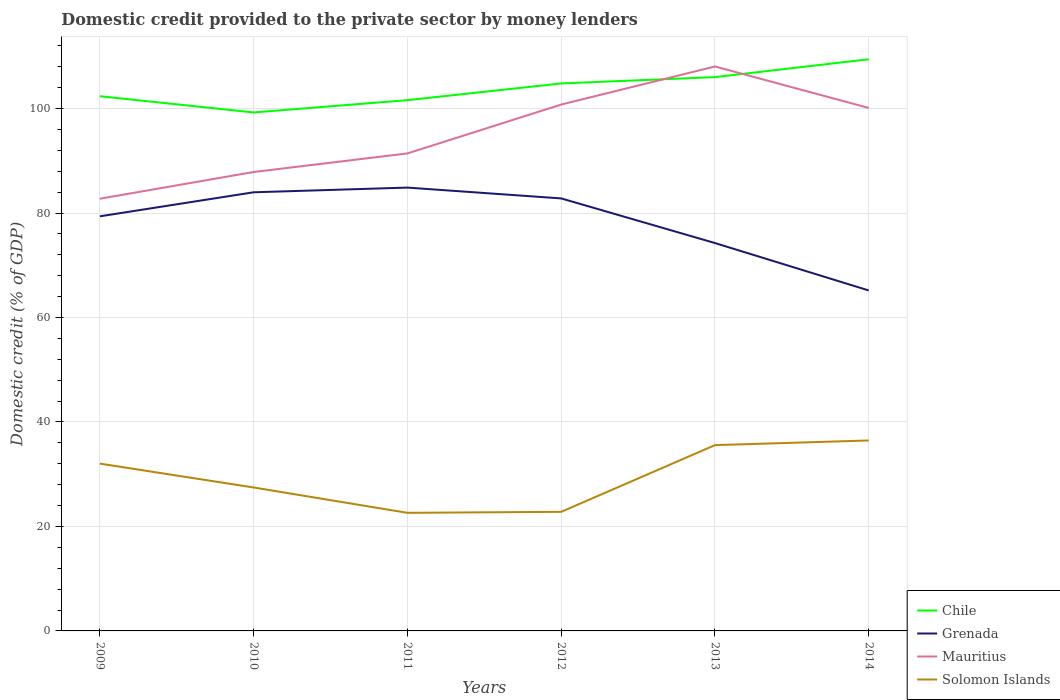How many different coloured lines are there?
Give a very brief answer. 4. Across all years, what is the maximum domestic credit provided to the private sector by money lenders in Chile?
Give a very brief answer. 99.27. What is the total domestic credit provided to the private sector by money lenders in Chile in the graph?
Your response must be concise. -5.55. What is the difference between the highest and the second highest domestic credit provided to the private sector by money lenders in Mauritius?
Make the answer very short. 25.33. What is the difference between the highest and the lowest domestic credit provided to the private sector by money lenders in Grenada?
Offer a terse response. 4. Is the domestic credit provided to the private sector by money lenders in Mauritius strictly greater than the domestic credit provided to the private sector by money lenders in Chile over the years?
Your answer should be very brief. No. Does the graph contain any zero values?
Offer a very short reply. No. How many legend labels are there?
Offer a terse response. 4. What is the title of the graph?
Your answer should be compact. Domestic credit provided to the private sector by money lenders. What is the label or title of the X-axis?
Ensure brevity in your answer.  Years. What is the label or title of the Y-axis?
Offer a very short reply. Domestic credit (% of GDP). What is the Domestic credit (% of GDP) of Chile in 2009?
Your answer should be compact. 102.37. What is the Domestic credit (% of GDP) in Grenada in 2009?
Provide a succinct answer. 79.38. What is the Domestic credit (% of GDP) of Mauritius in 2009?
Give a very brief answer. 82.74. What is the Domestic credit (% of GDP) of Solomon Islands in 2009?
Offer a terse response. 32.03. What is the Domestic credit (% of GDP) in Chile in 2010?
Your answer should be very brief. 99.27. What is the Domestic credit (% of GDP) of Grenada in 2010?
Provide a short and direct response. 83.98. What is the Domestic credit (% of GDP) in Mauritius in 2010?
Offer a very short reply. 87.86. What is the Domestic credit (% of GDP) in Solomon Islands in 2010?
Your response must be concise. 27.46. What is the Domestic credit (% of GDP) in Chile in 2011?
Provide a short and direct response. 101.62. What is the Domestic credit (% of GDP) in Grenada in 2011?
Your answer should be compact. 84.88. What is the Domestic credit (% of GDP) of Mauritius in 2011?
Ensure brevity in your answer.  91.42. What is the Domestic credit (% of GDP) of Solomon Islands in 2011?
Keep it short and to the point. 22.61. What is the Domestic credit (% of GDP) of Chile in 2012?
Offer a terse response. 104.82. What is the Domestic credit (% of GDP) of Grenada in 2012?
Your response must be concise. 82.8. What is the Domestic credit (% of GDP) of Mauritius in 2012?
Make the answer very short. 100.77. What is the Domestic credit (% of GDP) of Solomon Islands in 2012?
Your answer should be very brief. 22.8. What is the Domestic credit (% of GDP) in Chile in 2013?
Provide a short and direct response. 106.03. What is the Domestic credit (% of GDP) in Grenada in 2013?
Offer a very short reply. 74.26. What is the Domestic credit (% of GDP) in Mauritius in 2013?
Keep it short and to the point. 108.07. What is the Domestic credit (% of GDP) in Solomon Islands in 2013?
Offer a very short reply. 35.57. What is the Domestic credit (% of GDP) of Chile in 2014?
Offer a terse response. 109.45. What is the Domestic credit (% of GDP) of Grenada in 2014?
Provide a short and direct response. 65.18. What is the Domestic credit (% of GDP) of Mauritius in 2014?
Provide a succinct answer. 100.12. What is the Domestic credit (% of GDP) in Solomon Islands in 2014?
Ensure brevity in your answer.  36.46. Across all years, what is the maximum Domestic credit (% of GDP) of Chile?
Your answer should be compact. 109.45. Across all years, what is the maximum Domestic credit (% of GDP) in Grenada?
Provide a succinct answer. 84.88. Across all years, what is the maximum Domestic credit (% of GDP) of Mauritius?
Ensure brevity in your answer.  108.07. Across all years, what is the maximum Domestic credit (% of GDP) in Solomon Islands?
Give a very brief answer. 36.46. Across all years, what is the minimum Domestic credit (% of GDP) in Chile?
Offer a very short reply. 99.27. Across all years, what is the minimum Domestic credit (% of GDP) of Grenada?
Offer a very short reply. 65.18. Across all years, what is the minimum Domestic credit (% of GDP) in Mauritius?
Keep it short and to the point. 82.74. Across all years, what is the minimum Domestic credit (% of GDP) in Solomon Islands?
Provide a short and direct response. 22.61. What is the total Domestic credit (% of GDP) of Chile in the graph?
Your response must be concise. 623.55. What is the total Domestic credit (% of GDP) in Grenada in the graph?
Provide a short and direct response. 470.48. What is the total Domestic credit (% of GDP) of Mauritius in the graph?
Offer a very short reply. 570.99. What is the total Domestic credit (% of GDP) of Solomon Islands in the graph?
Provide a succinct answer. 176.94. What is the difference between the Domestic credit (% of GDP) in Chile in 2009 and that in 2010?
Offer a very short reply. 3.11. What is the difference between the Domestic credit (% of GDP) in Grenada in 2009 and that in 2010?
Offer a terse response. -4.6. What is the difference between the Domestic credit (% of GDP) of Mauritius in 2009 and that in 2010?
Give a very brief answer. -5.12. What is the difference between the Domestic credit (% of GDP) of Solomon Islands in 2009 and that in 2010?
Ensure brevity in your answer.  4.57. What is the difference between the Domestic credit (% of GDP) in Chile in 2009 and that in 2011?
Provide a short and direct response. 0.76. What is the difference between the Domestic credit (% of GDP) of Grenada in 2009 and that in 2011?
Your answer should be very brief. -5.5. What is the difference between the Domestic credit (% of GDP) of Mauritius in 2009 and that in 2011?
Your response must be concise. -8.67. What is the difference between the Domestic credit (% of GDP) of Solomon Islands in 2009 and that in 2011?
Your answer should be compact. 9.42. What is the difference between the Domestic credit (% of GDP) of Chile in 2009 and that in 2012?
Your response must be concise. -2.44. What is the difference between the Domestic credit (% of GDP) in Grenada in 2009 and that in 2012?
Provide a succinct answer. -3.43. What is the difference between the Domestic credit (% of GDP) of Mauritius in 2009 and that in 2012?
Ensure brevity in your answer.  -18.03. What is the difference between the Domestic credit (% of GDP) of Solomon Islands in 2009 and that in 2012?
Provide a succinct answer. 9.23. What is the difference between the Domestic credit (% of GDP) of Chile in 2009 and that in 2013?
Your response must be concise. -3.66. What is the difference between the Domestic credit (% of GDP) in Grenada in 2009 and that in 2013?
Offer a very short reply. 5.12. What is the difference between the Domestic credit (% of GDP) of Mauritius in 2009 and that in 2013?
Offer a terse response. -25.33. What is the difference between the Domestic credit (% of GDP) in Solomon Islands in 2009 and that in 2013?
Keep it short and to the point. -3.54. What is the difference between the Domestic credit (% of GDP) of Chile in 2009 and that in 2014?
Make the answer very short. -7.08. What is the difference between the Domestic credit (% of GDP) of Grenada in 2009 and that in 2014?
Offer a very short reply. 14.19. What is the difference between the Domestic credit (% of GDP) in Mauritius in 2009 and that in 2014?
Your response must be concise. -17.38. What is the difference between the Domestic credit (% of GDP) of Solomon Islands in 2009 and that in 2014?
Your response must be concise. -4.43. What is the difference between the Domestic credit (% of GDP) in Chile in 2010 and that in 2011?
Make the answer very short. -2.35. What is the difference between the Domestic credit (% of GDP) of Grenada in 2010 and that in 2011?
Your response must be concise. -0.9. What is the difference between the Domestic credit (% of GDP) of Mauritius in 2010 and that in 2011?
Your answer should be very brief. -3.55. What is the difference between the Domestic credit (% of GDP) in Solomon Islands in 2010 and that in 2011?
Offer a terse response. 4.85. What is the difference between the Domestic credit (% of GDP) in Chile in 2010 and that in 2012?
Your answer should be very brief. -5.55. What is the difference between the Domestic credit (% of GDP) in Grenada in 2010 and that in 2012?
Your answer should be compact. 1.18. What is the difference between the Domestic credit (% of GDP) of Mauritius in 2010 and that in 2012?
Keep it short and to the point. -12.91. What is the difference between the Domestic credit (% of GDP) of Solomon Islands in 2010 and that in 2012?
Your answer should be very brief. 4.66. What is the difference between the Domestic credit (% of GDP) of Chile in 2010 and that in 2013?
Provide a succinct answer. -6.76. What is the difference between the Domestic credit (% of GDP) in Grenada in 2010 and that in 2013?
Your answer should be very brief. 9.72. What is the difference between the Domestic credit (% of GDP) of Mauritius in 2010 and that in 2013?
Your answer should be very brief. -20.21. What is the difference between the Domestic credit (% of GDP) in Solomon Islands in 2010 and that in 2013?
Your answer should be compact. -8.11. What is the difference between the Domestic credit (% of GDP) in Chile in 2010 and that in 2014?
Your response must be concise. -10.18. What is the difference between the Domestic credit (% of GDP) in Grenada in 2010 and that in 2014?
Your answer should be very brief. 18.8. What is the difference between the Domestic credit (% of GDP) in Mauritius in 2010 and that in 2014?
Offer a terse response. -12.26. What is the difference between the Domestic credit (% of GDP) of Solomon Islands in 2010 and that in 2014?
Keep it short and to the point. -9. What is the difference between the Domestic credit (% of GDP) in Chile in 2011 and that in 2012?
Make the answer very short. -3.2. What is the difference between the Domestic credit (% of GDP) of Grenada in 2011 and that in 2012?
Keep it short and to the point. 2.07. What is the difference between the Domestic credit (% of GDP) of Mauritius in 2011 and that in 2012?
Ensure brevity in your answer.  -9.36. What is the difference between the Domestic credit (% of GDP) of Solomon Islands in 2011 and that in 2012?
Keep it short and to the point. -0.19. What is the difference between the Domestic credit (% of GDP) in Chile in 2011 and that in 2013?
Your answer should be compact. -4.41. What is the difference between the Domestic credit (% of GDP) of Grenada in 2011 and that in 2013?
Offer a very short reply. 10.62. What is the difference between the Domestic credit (% of GDP) in Mauritius in 2011 and that in 2013?
Provide a succinct answer. -16.65. What is the difference between the Domestic credit (% of GDP) of Solomon Islands in 2011 and that in 2013?
Give a very brief answer. -12.96. What is the difference between the Domestic credit (% of GDP) in Chile in 2011 and that in 2014?
Offer a terse response. -7.83. What is the difference between the Domestic credit (% of GDP) of Grenada in 2011 and that in 2014?
Your response must be concise. 19.69. What is the difference between the Domestic credit (% of GDP) of Mauritius in 2011 and that in 2014?
Keep it short and to the point. -8.71. What is the difference between the Domestic credit (% of GDP) in Solomon Islands in 2011 and that in 2014?
Provide a short and direct response. -13.85. What is the difference between the Domestic credit (% of GDP) of Chile in 2012 and that in 2013?
Your answer should be very brief. -1.21. What is the difference between the Domestic credit (% of GDP) in Grenada in 2012 and that in 2013?
Your answer should be very brief. 8.54. What is the difference between the Domestic credit (% of GDP) in Mauritius in 2012 and that in 2013?
Your response must be concise. -7.29. What is the difference between the Domestic credit (% of GDP) in Solomon Islands in 2012 and that in 2013?
Offer a very short reply. -12.77. What is the difference between the Domestic credit (% of GDP) of Chile in 2012 and that in 2014?
Provide a succinct answer. -4.63. What is the difference between the Domestic credit (% of GDP) in Grenada in 2012 and that in 2014?
Make the answer very short. 17.62. What is the difference between the Domestic credit (% of GDP) in Mauritius in 2012 and that in 2014?
Offer a very short reply. 0.65. What is the difference between the Domestic credit (% of GDP) of Solomon Islands in 2012 and that in 2014?
Your answer should be very brief. -13.66. What is the difference between the Domestic credit (% of GDP) of Chile in 2013 and that in 2014?
Offer a very short reply. -3.42. What is the difference between the Domestic credit (% of GDP) in Grenada in 2013 and that in 2014?
Your answer should be compact. 9.08. What is the difference between the Domestic credit (% of GDP) in Mauritius in 2013 and that in 2014?
Keep it short and to the point. 7.94. What is the difference between the Domestic credit (% of GDP) in Solomon Islands in 2013 and that in 2014?
Give a very brief answer. -0.89. What is the difference between the Domestic credit (% of GDP) of Chile in 2009 and the Domestic credit (% of GDP) of Grenada in 2010?
Keep it short and to the point. 18.39. What is the difference between the Domestic credit (% of GDP) of Chile in 2009 and the Domestic credit (% of GDP) of Mauritius in 2010?
Provide a short and direct response. 14.51. What is the difference between the Domestic credit (% of GDP) of Chile in 2009 and the Domestic credit (% of GDP) of Solomon Islands in 2010?
Offer a very short reply. 74.91. What is the difference between the Domestic credit (% of GDP) of Grenada in 2009 and the Domestic credit (% of GDP) of Mauritius in 2010?
Your response must be concise. -8.49. What is the difference between the Domestic credit (% of GDP) of Grenada in 2009 and the Domestic credit (% of GDP) of Solomon Islands in 2010?
Ensure brevity in your answer.  51.91. What is the difference between the Domestic credit (% of GDP) of Mauritius in 2009 and the Domestic credit (% of GDP) of Solomon Islands in 2010?
Make the answer very short. 55.28. What is the difference between the Domestic credit (% of GDP) in Chile in 2009 and the Domestic credit (% of GDP) in Grenada in 2011?
Offer a very short reply. 17.5. What is the difference between the Domestic credit (% of GDP) of Chile in 2009 and the Domestic credit (% of GDP) of Mauritius in 2011?
Your answer should be very brief. 10.96. What is the difference between the Domestic credit (% of GDP) in Chile in 2009 and the Domestic credit (% of GDP) in Solomon Islands in 2011?
Your answer should be compact. 79.76. What is the difference between the Domestic credit (% of GDP) of Grenada in 2009 and the Domestic credit (% of GDP) of Mauritius in 2011?
Make the answer very short. -12.04. What is the difference between the Domestic credit (% of GDP) in Grenada in 2009 and the Domestic credit (% of GDP) in Solomon Islands in 2011?
Your answer should be compact. 56.77. What is the difference between the Domestic credit (% of GDP) of Mauritius in 2009 and the Domestic credit (% of GDP) of Solomon Islands in 2011?
Provide a short and direct response. 60.13. What is the difference between the Domestic credit (% of GDP) in Chile in 2009 and the Domestic credit (% of GDP) in Grenada in 2012?
Keep it short and to the point. 19.57. What is the difference between the Domestic credit (% of GDP) of Chile in 2009 and the Domestic credit (% of GDP) of Mauritius in 2012?
Give a very brief answer. 1.6. What is the difference between the Domestic credit (% of GDP) of Chile in 2009 and the Domestic credit (% of GDP) of Solomon Islands in 2012?
Offer a very short reply. 79.57. What is the difference between the Domestic credit (% of GDP) of Grenada in 2009 and the Domestic credit (% of GDP) of Mauritius in 2012?
Your answer should be very brief. -21.4. What is the difference between the Domestic credit (% of GDP) in Grenada in 2009 and the Domestic credit (% of GDP) in Solomon Islands in 2012?
Ensure brevity in your answer.  56.58. What is the difference between the Domestic credit (% of GDP) in Mauritius in 2009 and the Domestic credit (% of GDP) in Solomon Islands in 2012?
Make the answer very short. 59.94. What is the difference between the Domestic credit (% of GDP) of Chile in 2009 and the Domestic credit (% of GDP) of Grenada in 2013?
Your response must be concise. 28.11. What is the difference between the Domestic credit (% of GDP) of Chile in 2009 and the Domestic credit (% of GDP) of Mauritius in 2013?
Offer a terse response. -5.7. What is the difference between the Domestic credit (% of GDP) in Chile in 2009 and the Domestic credit (% of GDP) in Solomon Islands in 2013?
Offer a very short reply. 66.8. What is the difference between the Domestic credit (% of GDP) in Grenada in 2009 and the Domestic credit (% of GDP) in Mauritius in 2013?
Keep it short and to the point. -28.69. What is the difference between the Domestic credit (% of GDP) in Grenada in 2009 and the Domestic credit (% of GDP) in Solomon Islands in 2013?
Your response must be concise. 43.8. What is the difference between the Domestic credit (% of GDP) of Mauritius in 2009 and the Domestic credit (% of GDP) of Solomon Islands in 2013?
Offer a terse response. 47.17. What is the difference between the Domestic credit (% of GDP) in Chile in 2009 and the Domestic credit (% of GDP) in Grenada in 2014?
Offer a very short reply. 37.19. What is the difference between the Domestic credit (% of GDP) in Chile in 2009 and the Domestic credit (% of GDP) in Mauritius in 2014?
Your answer should be very brief. 2.25. What is the difference between the Domestic credit (% of GDP) of Chile in 2009 and the Domestic credit (% of GDP) of Solomon Islands in 2014?
Offer a terse response. 65.91. What is the difference between the Domestic credit (% of GDP) of Grenada in 2009 and the Domestic credit (% of GDP) of Mauritius in 2014?
Provide a succinct answer. -20.75. What is the difference between the Domestic credit (% of GDP) of Grenada in 2009 and the Domestic credit (% of GDP) of Solomon Islands in 2014?
Give a very brief answer. 42.91. What is the difference between the Domestic credit (% of GDP) in Mauritius in 2009 and the Domestic credit (% of GDP) in Solomon Islands in 2014?
Offer a terse response. 46.28. What is the difference between the Domestic credit (% of GDP) in Chile in 2010 and the Domestic credit (% of GDP) in Grenada in 2011?
Give a very brief answer. 14.39. What is the difference between the Domestic credit (% of GDP) of Chile in 2010 and the Domestic credit (% of GDP) of Mauritius in 2011?
Your answer should be compact. 7.85. What is the difference between the Domestic credit (% of GDP) of Chile in 2010 and the Domestic credit (% of GDP) of Solomon Islands in 2011?
Offer a very short reply. 76.65. What is the difference between the Domestic credit (% of GDP) of Grenada in 2010 and the Domestic credit (% of GDP) of Mauritius in 2011?
Your answer should be compact. -7.44. What is the difference between the Domestic credit (% of GDP) in Grenada in 2010 and the Domestic credit (% of GDP) in Solomon Islands in 2011?
Make the answer very short. 61.37. What is the difference between the Domestic credit (% of GDP) of Mauritius in 2010 and the Domestic credit (% of GDP) of Solomon Islands in 2011?
Keep it short and to the point. 65.25. What is the difference between the Domestic credit (% of GDP) in Chile in 2010 and the Domestic credit (% of GDP) in Grenada in 2012?
Give a very brief answer. 16.46. What is the difference between the Domestic credit (% of GDP) of Chile in 2010 and the Domestic credit (% of GDP) of Mauritius in 2012?
Keep it short and to the point. -1.51. What is the difference between the Domestic credit (% of GDP) of Chile in 2010 and the Domestic credit (% of GDP) of Solomon Islands in 2012?
Your response must be concise. 76.47. What is the difference between the Domestic credit (% of GDP) of Grenada in 2010 and the Domestic credit (% of GDP) of Mauritius in 2012?
Provide a succinct answer. -16.79. What is the difference between the Domestic credit (% of GDP) of Grenada in 2010 and the Domestic credit (% of GDP) of Solomon Islands in 2012?
Make the answer very short. 61.18. What is the difference between the Domestic credit (% of GDP) in Mauritius in 2010 and the Domestic credit (% of GDP) in Solomon Islands in 2012?
Ensure brevity in your answer.  65.06. What is the difference between the Domestic credit (% of GDP) of Chile in 2010 and the Domestic credit (% of GDP) of Grenada in 2013?
Make the answer very short. 25. What is the difference between the Domestic credit (% of GDP) in Chile in 2010 and the Domestic credit (% of GDP) in Mauritius in 2013?
Provide a short and direct response. -8.8. What is the difference between the Domestic credit (% of GDP) in Chile in 2010 and the Domestic credit (% of GDP) in Solomon Islands in 2013?
Offer a very short reply. 63.69. What is the difference between the Domestic credit (% of GDP) of Grenada in 2010 and the Domestic credit (% of GDP) of Mauritius in 2013?
Keep it short and to the point. -24.09. What is the difference between the Domestic credit (% of GDP) of Grenada in 2010 and the Domestic credit (% of GDP) of Solomon Islands in 2013?
Keep it short and to the point. 48.41. What is the difference between the Domestic credit (% of GDP) of Mauritius in 2010 and the Domestic credit (% of GDP) of Solomon Islands in 2013?
Your answer should be compact. 52.29. What is the difference between the Domestic credit (% of GDP) of Chile in 2010 and the Domestic credit (% of GDP) of Grenada in 2014?
Make the answer very short. 34.08. What is the difference between the Domestic credit (% of GDP) in Chile in 2010 and the Domestic credit (% of GDP) in Mauritius in 2014?
Give a very brief answer. -0.86. What is the difference between the Domestic credit (% of GDP) in Chile in 2010 and the Domestic credit (% of GDP) in Solomon Islands in 2014?
Offer a terse response. 62.8. What is the difference between the Domestic credit (% of GDP) in Grenada in 2010 and the Domestic credit (% of GDP) in Mauritius in 2014?
Offer a terse response. -16.14. What is the difference between the Domestic credit (% of GDP) in Grenada in 2010 and the Domestic credit (% of GDP) in Solomon Islands in 2014?
Provide a short and direct response. 47.52. What is the difference between the Domestic credit (% of GDP) in Mauritius in 2010 and the Domestic credit (% of GDP) in Solomon Islands in 2014?
Your response must be concise. 51.4. What is the difference between the Domestic credit (% of GDP) of Chile in 2011 and the Domestic credit (% of GDP) of Grenada in 2012?
Your answer should be compact. 18.81. What is the difference between the Domestic credit (% of GDP) of Chile in 2011 and the Domestic credit (% of GDP) of Mauritius in 2012?
Provide a short and direct response. 0.84. What is the difference between the Domestic credit (% of GDP) of Chile in 2011 and the Domestic credit (% of GDP) of Solomon Islands in 2012?
Your answer should be very brief. 78.82. What is the difference between the Domestic credit (% of GDP) of Grenada in 2011 and the Domestic credit (% of GDP) of Mauritius in 2012?
Offer a terse response. -15.9. What is the difference between the Domestic credit (% of GDP) of Grenada in 2011 and the Domestic credit (% of GDP) of Solomon Islands in 2012?
Your response must be concise. 62.08. What is the difference between the Domestic credit (% of GDP) in Mauritius in 2011 and the Domestic credit (% of GDP) in Solomon Islands in 2012?
Offer a very short reply. 68.62. What is the difference between the Domestic credit (% of GDP) of Chile in 2011 and the Domestic credit (% of GDP) of Grenada in 2013?
Keep it short and to the point. 27.36. What is the difference between the Domestic credit (% of GDP) of Chile in 2011 and the Domestic credit (% of GDP) of Mauritius in 2013?
Your answer should be compact. -6.45. What is the difference between the Domestic credit (% of GDP) of Chile in 2011 and the Domestic credit (% of GDP) of Solomon Islands in 2013?
Make the answer very short. 66.04. What is the difference between the Domestic credit (% of GDP) of Grenada in 2011 and the Domestic credit (% of GDP) of Mauritius in 2013?
Make the answer very short. -23.19. What is the difference between the Domestic credit (% of GDP) of Grenada in 2011 and the Domestic credit (% of GDP) of Solomon Islands in 2013?
Offer a terse response. 49.3. What is the difference between the Domestic credit (% of GDP) in Mauritius in 2011 and the Domestic credit (% of GDP) in Solomon Islands in 2013?
Your response must be concise. 55.84. What is the difference between the Domestic credit (% of GDP) in Chile in 2011 and the Domestic credit (% of GDP) in Grenada in 2014?
Make the answer very short. 36.43. What is the difference between the Domestic credit (% of GDP) of Chile in 2011 and the Domestic credit (% of GDP) of Mauritius in 2014?
Make the answer very short. 1.49. What is the difference between the Domestic credit (% of GDP) in Chile in 2011 and the Domestic credit (% of GDP) in Solomon Islands in 2014?
Make the answer very short. 65.15. What is the difference between the Domestic credit (% of GDP) of Grenada in 2011 and the Domestic credit (% of GDP) of Mauritius in 2014?
Ensure brevity in your answer.  -15.25. What is the difference between the Domestic credit (% of GDP) in Grenada in 2011 and the Domestic credit (% of GDP) in Solomon Islands in 2014?
Keep it short and to the point. 48.41. What is the difference between the Domestic credit (% of GDP) in Mauritius in 2011 and the Domestic credit (% of GDP) in Solomon Islands in 2014?
Provide a short and direct response. 54.95. What is the difference between the Domestic credit (% of GDP) of Chile in 2012 and the Domestic credit (% of GDP) of Grenada in 2013?
Your response must be concise. 30.56. What is the difference between the Domestic credit (% of GDP) of Chile in 2012 and the Domestic credit (% of GDP) of Mauritius in 2013?
Ensure brevity in your answer.  -3.25. What is the difference between the Domestic credit (% of GDP) of Chile in 2012 and the Domestic credit (% of GDP) of Solomon Islands in 2013?
Offer a terse response. 69.24. What is the difference between the Domestic credit (% of GDP) in Grenada in 2012 and the Domestic credit (% of GDP) in Mauritius in 2013?
Offer a very short reply. -25.26. What is the difference between the Domestic credit (% of GDP) of Grenada in 2012 and the Domestic credit (% of GDP) of Solomon Islands in 2013?
Ensure brevity in your answer.  47.23. What is the difference between the Domestic credit (% of GDP) in Mauritius in 2012 and the Domestic credit (% of GDP) in Solomon Islands in 2013?
Offer a very short reply. 65.2. What is the difference between the Domestic credit (% of GDP) of Chile in 2012 and the Domestic credit (% of GDP) of Grenada in 2014?
Give a very brief answer. 39.63. What is the difference between the Domestic credit (% of GDP) in Chile in 2012 and the Domestic credit (% of GDP) in Mauritius in 2014?
Provide a succinct answer. 4.69. What is the difference between the Domestic credit (% of GDP) in Chile in 2012 and the Domestic credit (% of GDP) in Solomon Islands in 2014?
Make the answer very short. 68.35. What is the difference between the Domestic credit (% of GDP) of Grenada in 2012 and the Domestic credit (% of GDP) of Mauritius in 2014?
Provide a succinct answer. -17.32. What is the difference between the Domestic credit (% of GDP) in Grenada in 2012 and the Domestic credit (% of GDP) in Solomon Islands in 2014?
Keep it short and to the point. 46.34. What is the difference between the Domestic credit (% of GDP) of Mauritius in 2012 and the Domestic credit (% of GDP) of Solomon Islands in 2014?
Offer a very short reply. 64.31. What is the difference between the Domestic credit (% of GDP) in Chile in 2013 and the Domestic credit (% of GDP) in Grenada in 2014?
Your response must be concise. 40.84. What is the difference between the Domestic credit (% of GDP) in Chile in 2013 and the Domestic credit (% of GDP) in Mauritius in 2014?
Your answer should be compact. 5.9. What is the difference between the Domestic credit (% of GDP) in Chile in 2013 and the Domestic credit (% of GDP) in Solomon Islands in 2014?
Make the answer very short. 69.56. What is the difference between the Domestic credit (% of GDP) of Grenada in 2013 and the Domestic credit (% of GDP) of Mauritius in 2014?
Your answer should be compact. -25.86. What is the difference between the Domestic credit (% of GDP) in Grenada in 2013 and the Domestic credit (% of GDP) in Solomon Islands in 2014?
Your answer should be very brief. 37.8. What is the difference between the Domestic credit (% of GDP) in Mauritius in 2013 and the Domestic credit (% of GDP) in Solomon Islands in 2014?
Your answer should be compact. 71.6. What is the average Domestic credit (% of GDP) in Chile per year?
Ensure brevity in your answer.  103.92. What is the average Domestic credit (% of GDP) in Grenada per year?
Give a very brief answer. 78.41. What is the average Domestic credit (% of GDP) in Mauritius per year?
Provide a succinct answer. 95.16. What is the average Domestic credit (% of GDP) in Solomon Islands per year?
Offer a terse response. 29.49. In the year 2009, what is the difference between the Domestic credit (% of GDP) of Chile and Domestic credit (% of GDP) of Grenada?
Offer a very short reply. 23. In the year 2009, what is the difference between the Domestic credit (% of GDP) in Chile and Domestic credit (% of GDP) in Mauritius?
Your answer should be compact. 19.63. In the year 2009, what is the difference between the Domestic credit (% of GDP) of Chile and Domestic credit (% of GDP) of Solomon Islands?
Make the answer very short. 70.34. In the year 2009, what is the difference between the Domestic credit (% of GDP) of Grenada and Domestic credit (% of GDP) of Mauritius?
Give a very brief answer. -3.37. In the year 2009, what is the difference between the Domestic credit (% of GDP) of Grenada and Domestic credit (% of GDP) of Solomon Islands?
Keep it short and to the point. 47.35. In the year 2009, what is the difference between the Domestic credit (% of GDP) of Mauritius and Domestic credit (% of GDP) of Solomon Islands?
Offer a very short reply. 50.71. In the year 2010, what is the difference between the Domestic credit (% of GDP) of Chile and Domestic credit (% of GDP) of Grenada?
Your response must be concise. 15.29. In the year 2010, what is the difference between the Domestic credit (% of GDP) of Chile and Domestic credit (% of GDP) of Mauritius?
Provide a succinct answer. 11.4. In the year 2010, what is the difference between the Domestic credit (% of GDP) in Chile and Domestic credit (% of GDP) in Solomon Islands?
Your answer should be very brief. 71.8. In the year 2010, what is the difference between the Domestic credit (% of GDP) of Grenada and Domestic credit (% of GDP) of Mauritius?
Your answer should be very brief. -3.88. In the year 2010, what is the difference between the Domestic credit (% of GDP) of Grenada and Domestic credit (% of GDP) of Solomon Islands?
Your response must be concise. 56.52. In the year 2010, what is the difference between the Domestic credit (% of GDP) in Mauritius and Domestic credit (% of GDP) in Solomon Islands?
Offer a terse response. 60.4. In the year 2011, what is the difference between the Domestic credit (% of GDP) in Chile and Domestic credit (% of GDP) in Grenada?
Ensure brevity in your answer.  16.74. In the year 2011, what is the difference between the Domestic credit (% of GDP) of Chile and Domestic credit (% of GDP) of Mauritius?
Give a very brief answer. 10.2. In the year 2011, what is the difference between the Domestic credit (% of GDP) of Chile and Domestic credit (% of GDP) of Solomon Islands?
Keep it short and to the point. 79.01. In the year 2011, what is the difference between the Domestic credit (% of GDP) in Grenada and Domestic credit (% of GDP) in Mauritius?
Ensure brevity in your answer.  -6.54. In the year 2011, what is the difference between the Domestic credit (% of GDP) of Grenada and Domestic credit (% of GDP) of Solomon Islands?
Offer a very short reply. 62.27. In the year 2011, what is the difference between the Domestic credit (% of GDP) of Mauritius and Domestic credit (% of GDP) of Solomon Islands?
Your response must be concise. 68.81. In the year 2012, what is the difference between the Domestic credit (% of GDP) of Chile and Domestic credit (% of GDP) of Grenada?
Your response must be concise. 22.01. In the year 2012, what is the difference between the Domestic credit (% of GDP) of Chile and Domestic credit (% of GDP) of Mauritius?
Offer a terse response. 4.04. In the year 2012, what is the difference between the Domestic credit (% of GDP) of Chile and Domestic credit (% of GDP) of Solomon Islands?
Offer a terse response. 82.02. In the year 2012, what is the difference between the Domestic credit (% of GDP) in Grenada and Domestic credit (% of GDP) in Mauritius?
Make the answer very short. -17.97. In the year 2012, what is the difference between the Domestic credit (% of GDP) in Grenada and Domestic credit (% of GDP) in Solomon Islands?
Your answer should be compact. 60. In the year 2012, what is the difference between the Domestic credit (% of GDP) of Mauritius and Domestic credit (% of GDP) of Solomon Islands?
Offer a terse response. 77.97. In the year 2013, what is the difference between the Domestic credit (% of GDP) of Chile and Domestic credit (% of GDP) of Grenada?
Provide a succinct answer. 31.77. In the year 2013, what is the difference between the Domestic credit (% of GDP) in Chile and Domestic credit (% of GDP) in Mauritius?
Your answer should be very brief. -2.04. In the year 2013, what is the difference between the Domestic credit (% of GDP) in Chile and Domestic credit (% of GDP) in Solomon Islands?
Provide a short and direct response. 70.46. In the year 2013, what is the difference between the Domestic credit (% of GDP) in Grenada and Domestic credit (% of GDP) in Mauritius?
Provide a succinct answer. -33.81. In the year 2013, what is the difference between the Domestic credit (% of GDP) of Grenada and Domestic credit (% of GDP) of Solomon Islands?
Make the answer very short. 38.69. In the year 2013, what is the difference between the Domestic credit (% of GDP) of Mauritius and Domestic credit (% of GDP) of Solomon Islands?
Give a very brief answer. 72.5. In the year 2014, what is the difference between the Domestic credit (% of GDP) of Chile and Domestic credit (% of GDP) of Grenada?
Your answer should be very brief. 44.26. In the year 2014, what is the difference between the Domestic credit (% of GDP) in Chile and Domestic credit (% of GDP) in Mauritius?
Provide a succinct answer. 9.32. In the year 2014, what is the difference between the Domestic credit (% of GDP) in Chile and Domestic credit (% of GDP) in Solomon Islands?
Your answer should be very brief. 72.98. In the year 2014, what is the difference between the Domestic credit (% of GDP) of Grenada and Domestic credit (% of GDP) of Mauritius?
Offer a terse response. -34.94. In the year 2014, what is the difference between the Domestic credit (% of GDP) in Grenada and Domestic credit (% of GDP) in Solomon Islands?
Provide a short and direct response. 28.72. In the year 2014, what is the difference between the Domestic credit (% of GDP) in Mauritius and Domestic credit (% of GDP) in Solomon Islands?
Give a very brief answer. 63.66. What is the ratio of the Domestic credit (% of GDP) in Chile in 2009 to that in 2010?
Offer a very short reply. 1.03. What is the ratio of the Domestic credit (% of GDP) of Grenada in 2009 to that in 2010?
Your response must be concise. 0.95. What is the ratio of the Domestic credit (% of GDP) of Mauritius in 2009 to that in 2010?
Ensure brevity in your answer.  0.94. What is the ratio of the Domestic credit (% of GDP) in Solomon Islands in 2009 to that in 2010?
Offer a terse response. 1.17. What is the ratio of the Domestic credit (% of GDP) in Chile in 2009 to that in 2011?
Offer a very short reply. 1.01. What is the ratio of the Domestic credit (% of GDP) in Grenada in 2009 to that in 2011?
Your answer should be very brief. 0.94. What is the ratio of the Domestic credit (% of GDP) in Mauritius in 2009 to that in 2011?
Make the answer very short. 0.91. What is the ratio of the Domestic credit (% of GDP) of Solomon Islands in 2009 to that in 2011?
Provide a succinct answer. 1.42. What is the ratio of the Domestic credit (% of GDP) in Chile in 2009 to that in 2012?
Make the answer very short. 0.98. What is the ratio of the Domestic credit (% of GDP) of Grenada in 2009 to that in 2012?
Give a very brief answer. 0.96. What is the ratio of the Domestic credit (% of GDP) of Mauritius in 2009 to that in 2012?
Offer a very short reply. 0.82. What is the ratio of the Domestic credit (% of GDP) of Solomon Islands in 2009 to that in 2012?
Offer a terse response. 1.4. What is the ratio of the Domestic credit (% of GDP) of Chile in 2009 to that in 2013?
Offer a very short reply. 0.97. What is the ratio of the Domestic credit (% of GDP) of Grenada in 2009 to that in 2013?
Provide a short and direct response. 1.07. What is the ratio of the Domestic credit (% of GDP) of Mauritius in 2009 to that in 2013?
Provide a succinct answer. 0.77. What is the ratio of the Domestic credit (% of GDP) in Solomon Islands in 2009 to that in 2013?
Keep it short and to the point. 0.9. What is the ratio of the Domestic credit (% of GDP) in Chile in 2009 to that in 2014?
Your answer should be compact. 0.94. What is the ratio of the Domestic credit (% of GDP) of Grenada in 2009 to that in 2014?
Keep it short and to the point. 1.22. What is the ratio of the Domestic credit (% of GDP) of Mauritius in 2009 to that in 2014?
Your answer should be very brief. 0.83. What is the ratio of the Domestic credit (% of GDP) of Solomon Islands in 2009 to that in 2014?
Your answer should be very brief. 0.88. What is the ratio of the Domestic credit (% of GDP) in Chile in 2010 to that in 2011?
Offer a terse response. 0.98. What is the ratio of the Domestic credit (% of GDP) of Grenada in 2010 to that in 2011?
Give a very brief answer. 0.99. What is the ratio of the Domestic credit (% of GDP) in Mauritius in 2010 to that in 2011?
Your answer should be compact. 0.96. What is the ratio of the Domestic credit (% of GDP) of Solomon Islands in 2010 to that in 2011?
Offer a very short reply. 1.21. What is the ratio of the Domestic credit (% of GDP) in Chile in 2010 to that in 2012?
Ensure brevity in your answer.  0.95. What is the ratio of the Domestic credit (% of GDP) in Grenada in 2010 to that in 2012?
Offer a very short reply. 1.01. What is the ratio of the Domestic credit (% of GDP) in Mauritius in 2010 to that in 2012?
Your response must be concise. 0.87. What is the ratio of the Domestic credit (% of GDP) of Solomon Islands in 2010 to that in 2012?
Provide a succinct answer. 1.2. What is the ratio of the Domestic credit (% of GDP) of Chile in 2010 to that in 2013?
Your response must be concise. 0.94. What is the ratio of the Domestic credit (% of GDP) of Grenada in 2010 to that in 2013?
Provide a succinct answer. 1.13. What is the ratio of the Domestic credit (% of GDP) of Mauritius in 2010 to that in 2013?
Ensure brevity in your answer.  0.81. What is the ratio of the Domestic credit (% of GDP) in Solomon Islands in 2010 to that in 2013?
Your answer should be compact. 0.77. What is the ratio of the Domestic credit (% of GDP) in Chile in 2010 to that in 2014?
Keep it short and to the point. 0.91. What is the ratio of the Domestic credit (% of GDP) in Grenada in 2010 to that in 2014?
Make the answer very short. 1.29. What is the ratio of the Domestic credit (% of GDP) in Mauritius in 2010 to that in 2014?
Keep it short and to the point. 0.88. What is the ratio of the Domestic credit (% of GDP) of Solomon Islands in 2010 to that in 2014?
Make the answer very short. 0.75. What is the ratio of the Domestic credit (% of GDP) in Chile in 2011 to that in 2012?
Offer a very short reply. 0.97. What is the ratio of the Domestic credit (% of GDP) of Grenada in 2011 to that in 2012?
Make the answer very short. 1.02. What is the ratio of the Domestic credit (% of GDP) in Mauritius in 2011 to that in 2012?
Ensure brevity in your answer.  0.91. What is the ratio of the Domestic credit (% of GDP) of Solomon Islands in 2011 to that in 2012?
Make the answer very short. 0.99. What is the ratio of the Domestic credit (% of GDP) of Chile in 2011 to that in 2013?
Give a very brief answer. 0.96. What is the ratio of the Domestic credit (% of GDP) in Grenada in 2011 to that in 2013?
Provide a succinct answer. 1.14. What is the ratio of the Domestic credit (% of GDP) of Mauritius in 2011 to that in 2013?
Your response must be concise. 0.85. What is the ratio of the Domestic credit (% of GDP) of Solomon Islands in 2011 to that in 2013?
Your answer should be compact. 0.64. What is the ratio of the Domestic credit (% of GDP) of Chile in 2011 to that in 2014?
Provide a short and direct response. 0.93. What is the ratio of the Domestic credit (% of GDP) in Grenada in 2011 to that in 2014?
Offer a very short reply. 1.3. What is the ratio of the Domestic credit (% of GDP) in Mauritius in 2011 to that in 2014?
Your answer should be compact. 0.91. What is the ratio of the Domestic credit (% of GDP) in Solomon Islands in 2011 to that in 2014?
Offer a very short reply. 0.62. What is the ratio of the Domestic credit (% of GDP) of Grenada in 2012 to that in 2013?
Keep it short and to the point. 1.12. What is the ratio of the Domestic credit (% of GDP) in Mauritius in 2012 to that in 2013?
Make the answer very short. 0.93. What is the ratio of the Domestic credit (% of GDP) in Solomon Islands in 2012 to that in 2013?
Your answer should be very brief. 0.64. What is the ratio of the Domestic credit (% of GDP) in Chile in 2012 to that in 2014?
Your response must be concise. 0.96. What is the ratio of the Domestic credit (% of GDP) in Grenada in 2012 to that in 2014?
Your answer should be compact. 1.27. What is the ratio of the Domestic credit (% of GDP) of Solomon Islands in 2012 to that in 2014?
Offer a terse response. 0.63. What is the ratio of the Domestic credit (% of GDP) in Chile in 2013 to that in 2014?
Make the answer very short. 0.97. What is the ratio of the Domestic credit (% of GDP) in Grenada in 2013 to that in 2014?
Ensure brevity in your answer.  1.14. What is the ratio of the Domestic credit (% of GDP) in Mauritius in 2013 to that in 2014?
Offer a terse response. 1.08. What is the ratio of the Domestic credit (% of GDP) of Solomon Islands in 2013 to that in 2014?
Provide a short and direct response. 0.98. What is the difference between the highest and the second highest Domestic credit (% of GDP) in Chile?
Give a very brief answer. 3.42. What is the difference between the highest and the second highest Domestic credit (% of GDP) in Grenada?
Offer a very short reply. 0.9. What is the difference between the highest and the second highest Domestic credit (% of GDP) of Mauritius?
Offer a terse response. 7.29. What is the difference between the highest and the second highest Domestic credit (% of GDP) of Solomon Islands?
Your response must be concise. 0.89. What is the difference between the highest and the lowest Domestic credit (% of GDP) in Chile?
Give a very brief answer. 10.18. What is the difference between the highest and the lowest Domestic credit (% of GDP) in Grenada?
Keep it short and to the point. 19.69. What is the difference between the highest and the lowest Domestic credit (% of GDP) in Mauritius?
Provide a succinct answer. 25.33. What is the difference between the highest and the lowest Domestic credit (% of GDP) in Solomon Islands?
Your response must be concise. 13.85. 